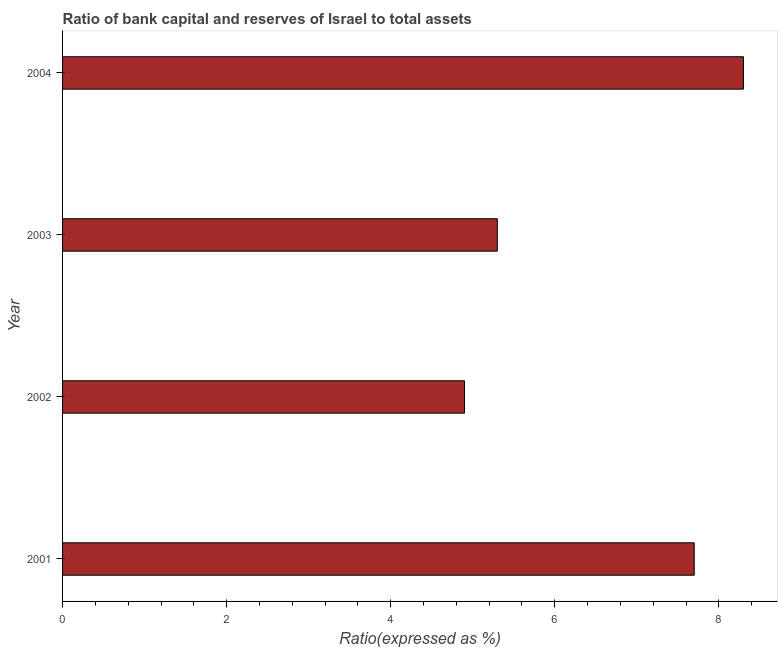Does the graph contain any zero values?
Ensure brevity in your answer.  No. Does the graph contain grids?
Keep it short and to the point. No. What is the title of the graph?
Ensure brevity in your answer.  Ratio of bank capital and reserves of Israel to total assets. What is the label or title of the X-axis?
Provide a succinct answer. Ratio(expressed as %). What is the bank capital to assets ratio in 2002?
Your response must be concise. 4.9. Across all years, what is the minimum bank capital to assets ratio?
Ensure brevity in your answer.  4.9. In which year was the bank capital to assets ratio minimum?
Offer a terse response. 2002. What is the sum of the bank capital to assets ratio?
Your answer should be very brief. 26.2. What is the difference between the bank capital to assets ratio in 2001 and 2002?
Provide a succinct answer. 2.8. What is the average bank capital to assets ratio per year?
Offer a terse response. 6.55. What is the median bank capital to assets ratio?
Your answer should be compact. 6.5. In how many years, is the bank capital to assets ratio greater than 1.2 %?
Ensure brevity in your answer.  4. What is the ratio of the bank capital to assets ratio in 2001 to that in 2003?
Give a very brief answer. 1.45. Is the bank capital to assets ratio in 2003 less than that in 2004?
Keep it short and to the point. Yes. What is the difference between the highest and the lowest bank capital to assets ratio?
Provide a short and direct response. 3.4. In how many years, is the bank capital to assets ratio greater than the average bank capital to assets ratio taken over all years?
Your answer should be compact. 2. How many bars are there?
Keep it short and to the point. 4. What is the Ratio(expressed as %) of 2001?
Keep it short and to the point. 7.7. What is the Ratio(expressed as %) of 2002?
Make the answer very short. 4.9. What is the difference between the Ratio(expressed as %) in 2002 and 2003?
Ensure brevity in your answer.  -0.4. What is the ratio of the Ratio(expressed as %) in 2001 to that in 2002?
Your answer should be compact. 1.57. What is the ratio of the Ratio(expressed as %) in 2001 to that in 2003?
Ensure brevity in your answer.  1.45. What is the ratio of the Ratio(expressed as %) in 2001 to that in 2004?
Give a very brief answer. 0.93. What is the ratio of the Ratio(expressed as %) in 2002 to that in 2003?
Your answer should be very brief. 0.93. What is the ratio of the Ratio(expressed as %) in 2002 to that in 2004?
Offer a terse response. 0.59. What is the ratio of the Ratio(expressed as %) in 2003 to that in 2004?
Provide a short and direct response. 0.64. 